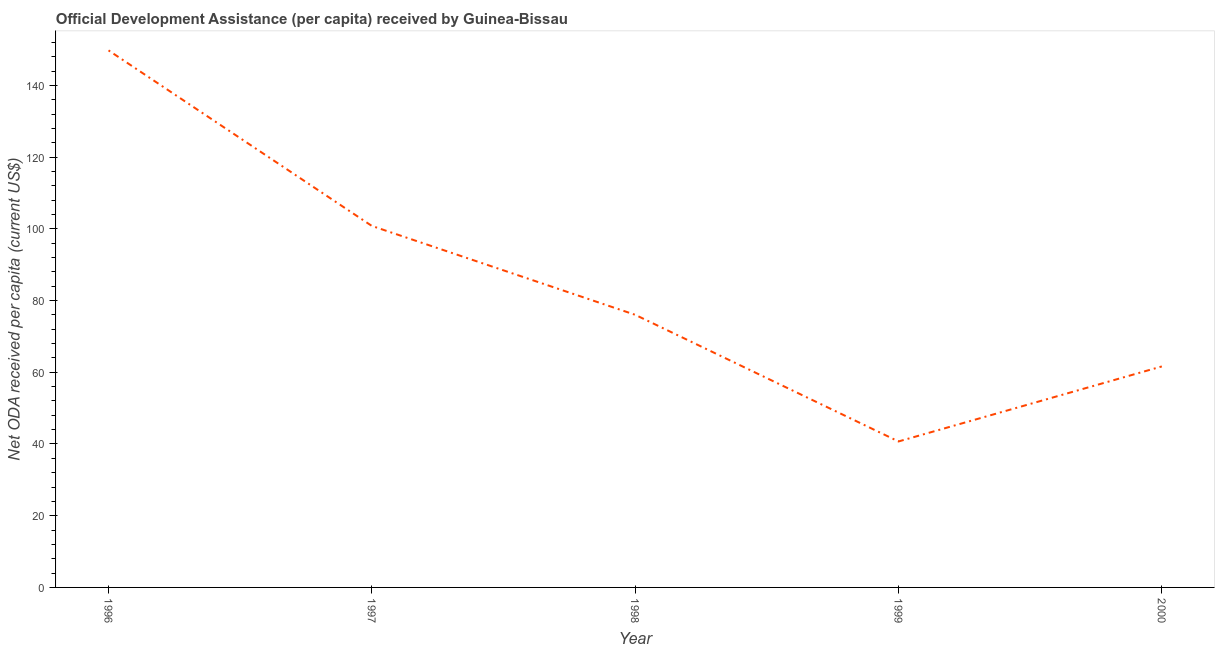What is the net oda received per capita in 1999?
Give a very brief answer. 40.71. Across all years, what is the maximum net oda received per capita?
Your answer should be compact. 149.77. Across all years, what is the minimum net oda received per capita?
Keep it short and to the point. 40.71. In which year was the net oda received per capita maximum?
Provide a succinct answer. 1996. In which year was the net oda received per capita minimum?
Offer a terse response. 1999. What is the sum of the net oda received per capita?
Provide a succinct answer. 428.94. What is the difference between the net oda received per capita in 1997 and 2000?
Provide a short and direct response. 39.18. What is the average net oda received per capita per year?
Your response must be concise. 85.79. What is the median net oda received per capita?
Provide a short and direct response. 76.03. In how many years, is the net oda received per capita greater than 120 US$?
Make the answer very short. 1. Do a majority of the years between 1998 and 1996 (inclusive) have net oda received per capita greater than 84 US$?
Keep it short and to the point. No. What is the ratio of the net oda received per capita in 1996 to that in 1997?
Make the answer very short. 1.49. Is the net oda received per capita in 1998 less than that in 2000?
Make the answer very short. No. Is the difference between the net oda received per capita in 1997 and 1999 greater than the difference between any two years?
Give a very brief answer. No. What is the difference between the highest and the second highest net oda received per capita?
Your response must be concise. 48.96. Is the sum of the net oda received per capita in 1998 and 2000 greater than the maximum net oda received per capita across all years?
Make the answer very short. No. What is the difference between the highest and the lowest net oda received per capita?
Your answer should be compact. 109.06. Does the net oda received per capita monotonically increase over the years?
Make the answer very short. No. How many lines are there?
Provide a succinct answer. 1. How many years are there in the graph?
Your answer should be compact. 5. What is the difference between two consecutive major ticks on the Y-axis?
Your answer should be compact. 20. Are the values on the major ticks of Y-axis written in scientific E-notation?
Your answer should be compact. No. What is the title of the graph?
Keep it short and to the point. Official Development Assistance (per capita) received by Guinea-Bissau. What is the label or title of the Y-axis?
Give a very brief answer. Net ODA received per capita (current US$). What is the Net ODA received per capita (current US$) in 1996?
Keep it short and to the point. 149.77. What is the Net ODA received per capita (current US$) in 1997?
Make the answer very short. 100.81. What is the Net ODA received per capita (current US$) in 1998?
Offer a very short reply. 76.03. What is the Net ODA received per capita (current US$) of 1999?
Your answer should be very brief. 40.71. What is the Net ODA received per capita (current US$) in 2000?
Make the answer very short. 61.63. What is the difference between the Net ODA received per capita (current US$) in 1996 and 1997?
Your answer should be very brief. 48.96. What is the difference between the Net ODA received per capita (current US$) in 1996 and 1998?
Provide a short and direct response. 73.74. What is the difference between the Net ODA received per capita (current US$) in 1996 and 1999?
Your response must be concise. 109.06. What is the difference between the Net ODA received per capita (current US$) in 1996 and 2000?
Make the answer very short. 88.14. What is the difference between the Net ODA received per capita (current US$) in 1997 and 1998?
Provide a short and direct response. 24.78. What is the difference between the Net ODA received per capita (current US$) in 1997 and 1999?
Your answer should be compact. 60.1. What is the difference between the Net ODA received per capita (current US$) in 1997 and 2000?
Offer a very short reply. 39.18. What is the difference between the Net ODA received per capita (current US$) in 1998 and 1999?
Provide a succinct answer. 35.32. What is the difference between the Net ODA received per capita (current US$) in 1998 and 2000?
Your answer should be compact. 14.4. What is the difference between the Net ODA received per capita (current US$) in 1999 and 2000?
Offer a very short reply. -20.92. What is the ratio of the Net ODA received per capita (current US$) in 1996 to that in 1997?
Keep it short and to the point. 1.49. What is the ratio of the Net ODA received per capita (current US$) in 1996 to that in 1998?
Provide a short and direct response. 1.97. What is the ratio of the Net ODA received per capita (current US$) in 1996 to that in 1999?
Offer a very short reply. 3.68. What is the ratio of the Net ODA received per capita (current US$) in 1996 to that in 2000?
Your answer should be compact. 2.43. What is the ratio of the Net ODA received per capita (current US$) in 1997 to that in 1998?
Offer a terse response. 1.33. What is the ratio of the Net ODA received per capita (current US$) in 1997 to that in 1999?
Offer a very short reply. 2.48. What is the ratio of the Net ODA received per capita (current US$) in 1997 to that in 2000?
Your answer should be very brief. 1.64. What is the ratio of the Net ODA received per capita (current US$) in 1998 to that in 1999?
Provide a succinct answer. 1.87. What is the ratio of the Net ODA received per capita (current US$) in 1998 to that in 2000?
Offer a very short reply. 1.23. What is the ratio of the Net ODA received per capita (current US$) in 1999 to that in 2000?
Make the answer very short. 0.66. 